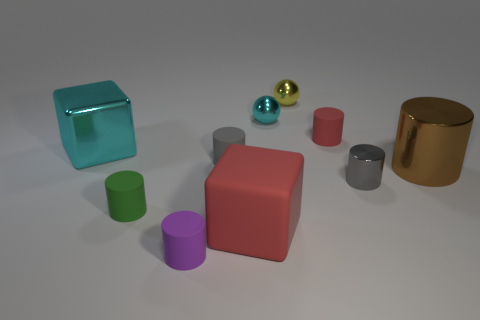Subtract all green cylinders. How many cylinders are left? 5 Subtract all metal cylinders. How many cylinders are left? 4 Subtract all purple cylinders. Subtract all red spheres. How many cylinders are left? 5 Subtract all blocks. How many objects are left? 8 Subtract 1 green cylinders. How many objects are left? 9 Subtract all cyan metal balls. Subtract all brown cylinders. How many objects are left? 8 Add 5 tiny purple cylinders. How many tiny purple cylinders are left? 6 Add 1 metal spheres. How many metal spheres exist? 3 